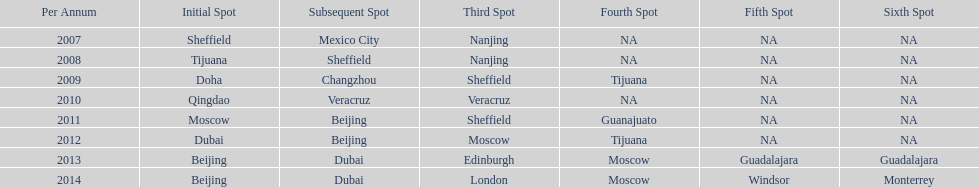Which year is previous to 2011 2010. 